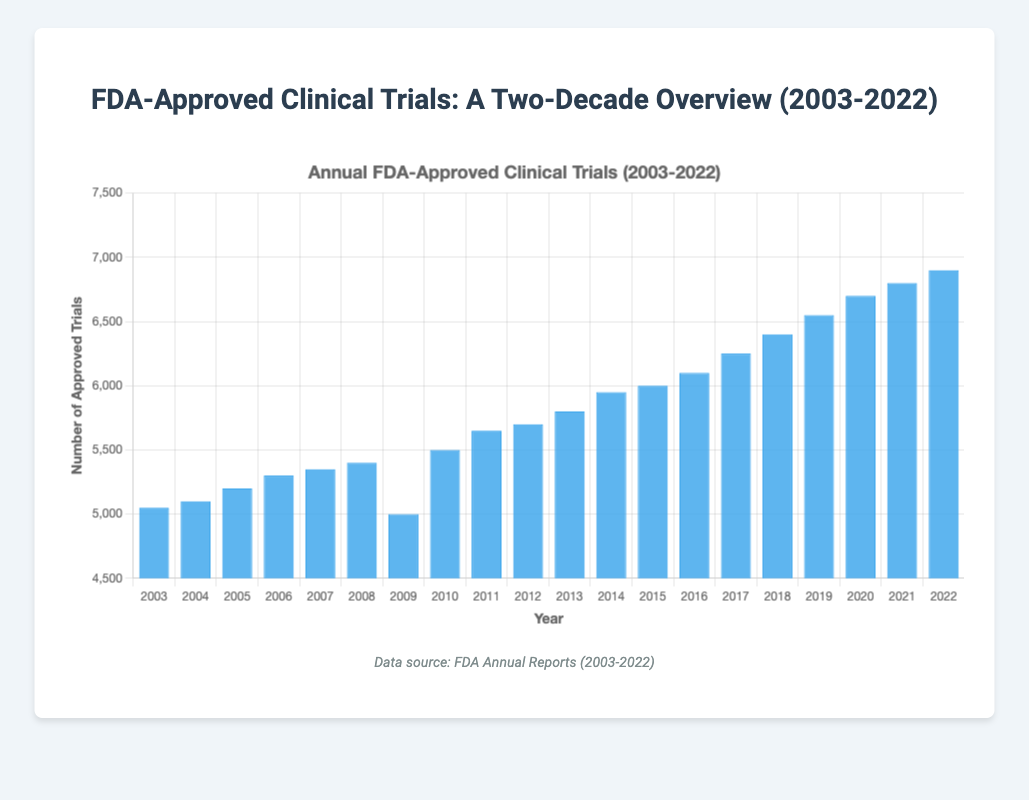how many clinical trials were approved in 2009? The bar representing 2009 shows the number of trials approved as 5000.
Answer: 5000 which year had the highest number of FDA-approved clinical trials? The bar for 2022 is the tallest, indicating that 2022 had the highest number of approved trials at 6900.
Answer: 2022 how does the number of FDA-approved trials in 2022 compare to 2003? The number of approved trials in 2022 (6900) is significantly higher than in 2003 (5050).
Answer: 2022 had more trials than 2003 what is the total number of clinical trials approved between 2003 and 2005? Sum the values from 2003, 2004, and 2005 (5050 + 5100 + 5200) to get the total number of trials approved.
Answer: 15350 what is the average number of clinical trials approved per year from 2010 to 2015? Sum the values from 2010 to 2015 (5500 + 5650 + 5700 + 5800 + 5950 + 6000) and then divide by the number of years, which is 6.
Answer: 5766.67 in which year did the number of FDA-approved clinical trials drop compared to the previous year? The only drop occurs between 2008 and 2009, where the number decreases from 5400 to 5000.
Answer: 2009 what is the median number of clinical trials approved annually from 2003 to 2022? Arrange the numbers in ascending order and find the middle value. Here, the median is the average of the 10th and 11th values (5700 and 5800).
Answer: 5750 which year experienced the largest annual increase in FDA-approved clinical trials? Calculate the annual differences and find the largest. The difference between 2009 (5000) and 2010 (5500) is the largest (500).
Answer: 2010 how does the growth in the number of trials from 2003 to 2022 compare to the growth from 2003 to 2013? From 2003 to 2022, the growth is 6900 - 5050 = 1850, while from 2003 to 2013, it's 5800 - 5050 = 750. The growth is larger from 2003 to 2022.
Answer: Larger growth from 2003 to 2022 what visual attribute makes it easy to identify the trend in the number of clinical trials approved over the years? The height of the blue bars representing the number of trials each year visually shows an upward trend.
Answer: Height of blue bars which year had the smallest increase in the number of approved clinical trials compared to the previous year? The smallest increase is between 2006 and 2007, which is only 50 (5300 to 5350).
Answer: 2007 